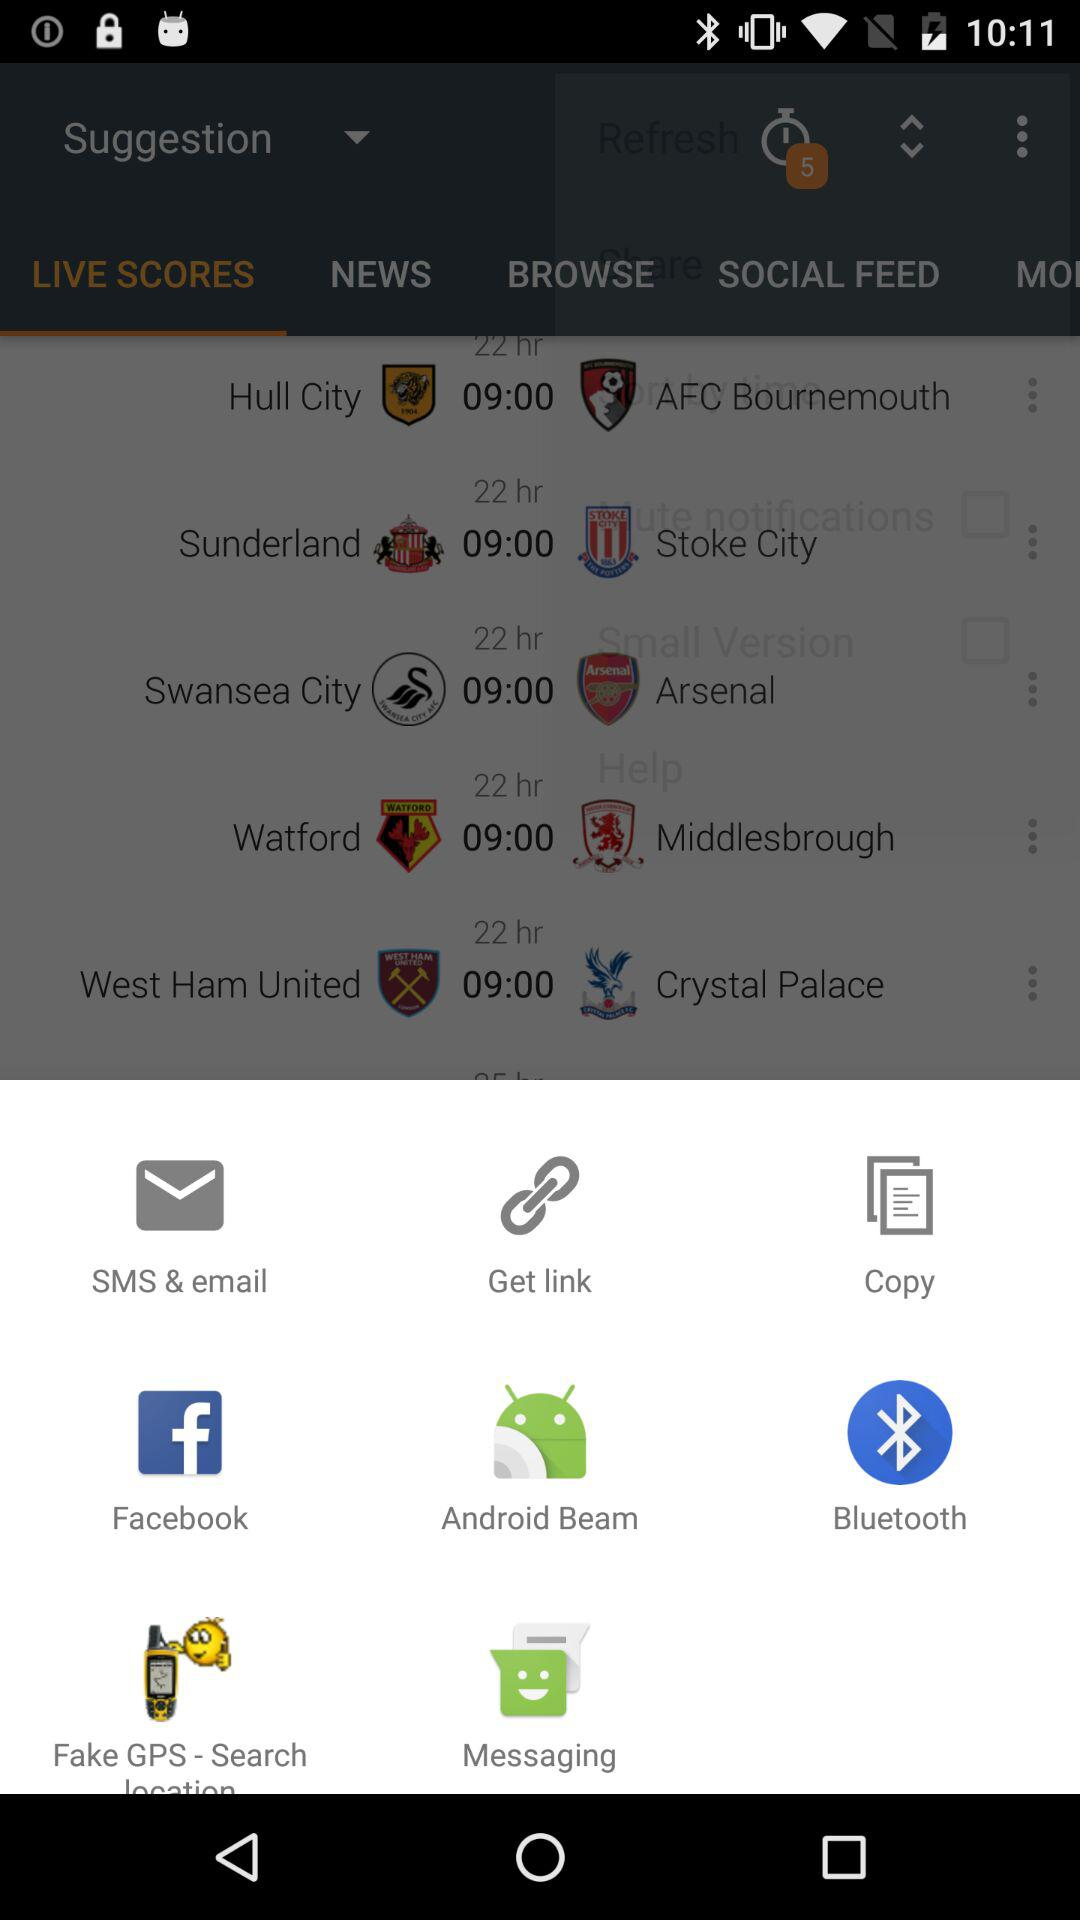Which tab is open? The open tab is "LIVE SCORES". 